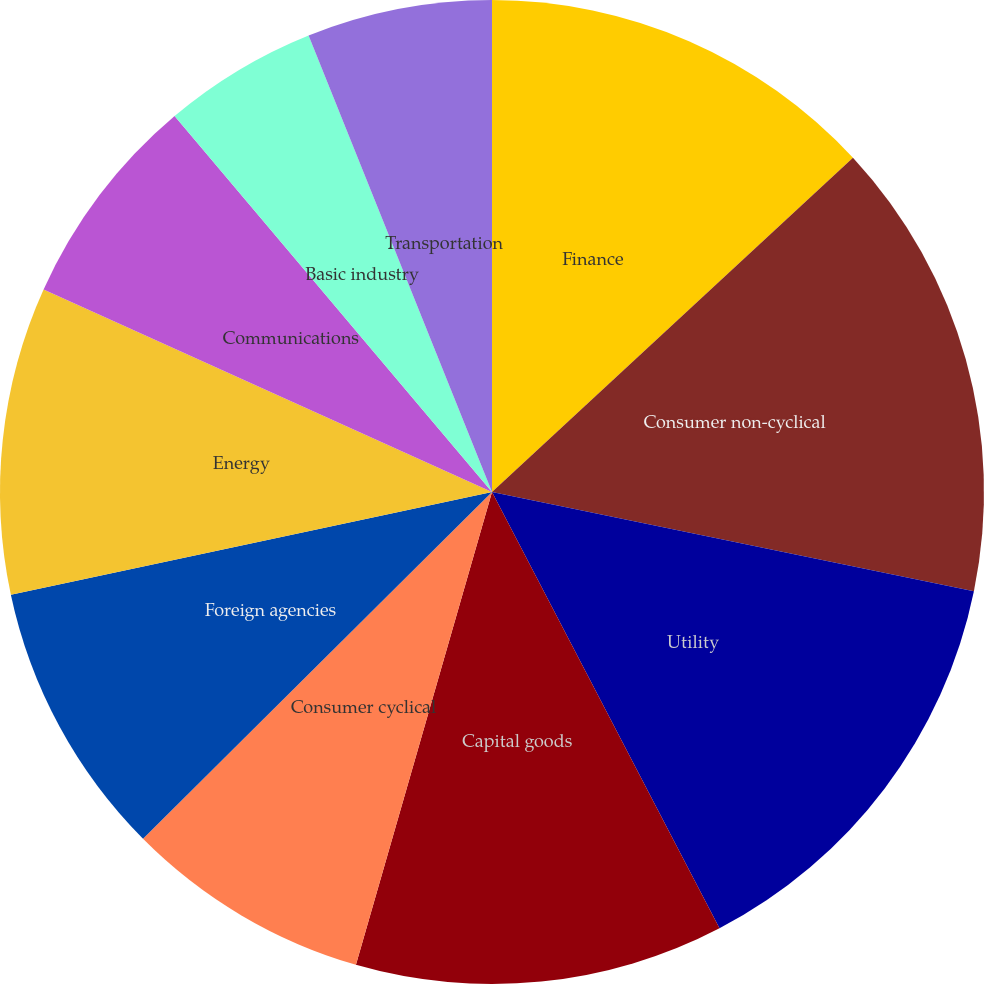Convert chart. <chart><loc_0><loc_0><loc_500><loc_500><pie_chart><fcel>Finance<fcel>Consumer non-cyclical<fcel>Utility<fcel>Capital goods<fcel>Consumer cyclical<fcel>Foreign agencies<fcel>Energy<fcel>Communications<fcel>Basic industry<fcel>Transportation<nl><fcel>13.11%<fcel>15.12%<fcel>14.12%<fcel>12.11%<fcel>8.09%<fcel>9.1%<fcel>10.1%<fcel>7.09%<fcel>5.08%<fcel>6.08%<nl></chart> 